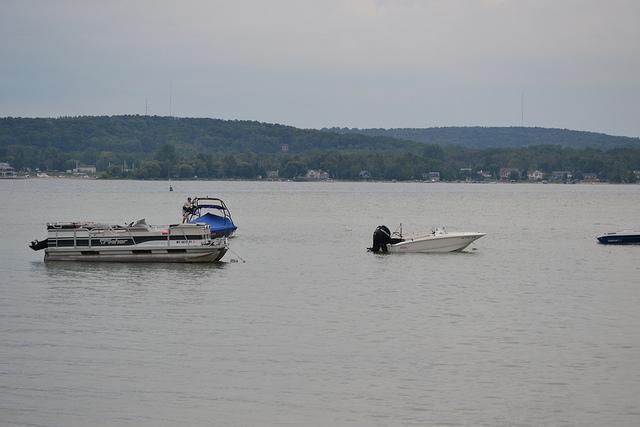How many boats are on the water?
Give a very brief answer. 4. How many boats are there?
Give a very brief answer. 4. How many boats are in the water?
Give a very brief answer. 4. How many people are in the boat?
Give a very brief answer. 1. How many windmills are in this picture?
Give a very brief answer. 0. How many boats on the water?
Give a very brief answer. 4. How many boats are in the picture?
Give a very brief answer. 2. 